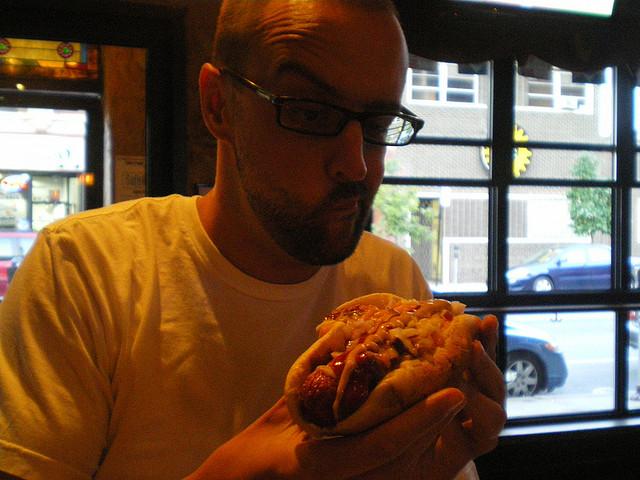How many cars do you see in the background?
Concise answer only. 3. What type of food is the man eating?
Write a very short answer. Hot dog. Why is the man raising his eyebrow?
Give a very brief answer. He loves his food. 